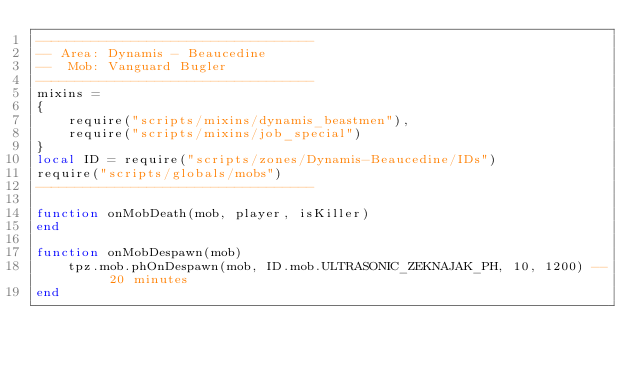Convert code to text. <code><loc_0><loc_0><loc_500><loc_500><_Lua_>-----------------------------------
-- Area: Dynamis - Beaucedine
--  Mob: Vanguard Bugler
-----------------------------------
mixins =
{
    require("scripts/mixins/dynamis_beastmen"),
    require("scripts/mixins/job_special")
}
local ID = require("scripts/zones/Dynamis-Beaucedine/IDs")
require("scripts/globals/mobs")
-----------------------------------

function onMobDeath(mob, player, isKiller)
end

function onMobDespawn(mob)
    tpz.mob.phOnDespawn(mob, ID.mob.ULTRASONIC_ZEKNAJAK_PH, 10, 1200) -- 20 minutes
end
</code> 